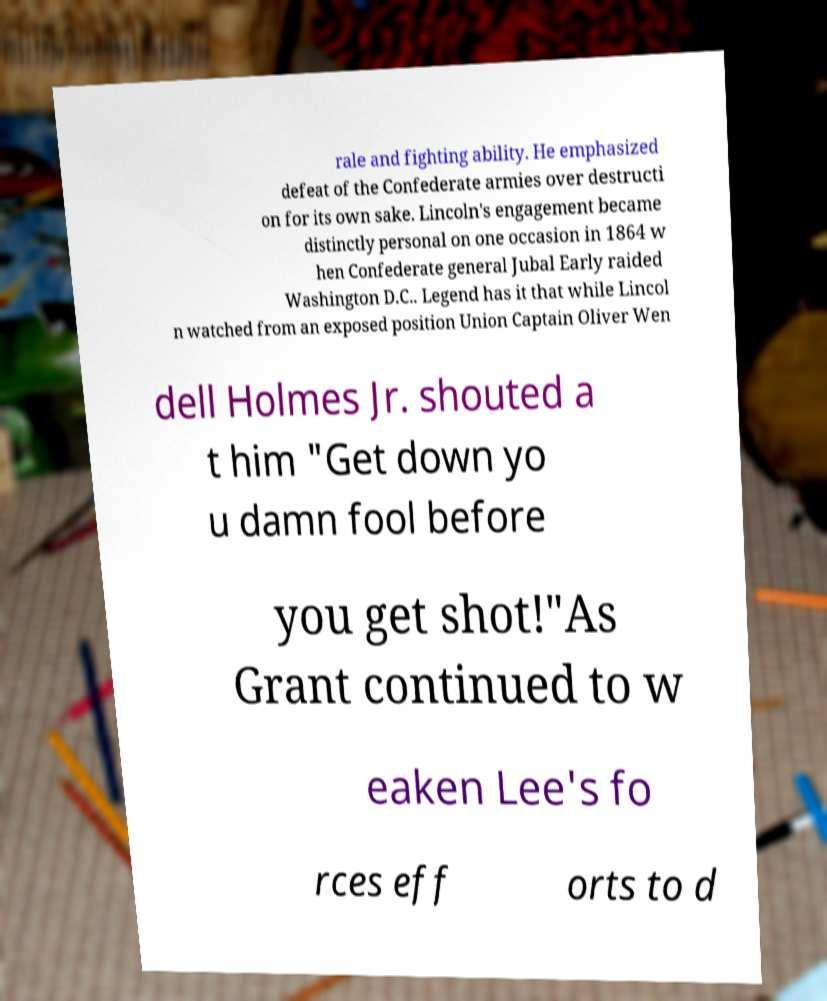Can you read and provide the text displayed in the image?This photo seems to have some interesting text. Can you extract and type it out for me? rale and fighting ability. He emphasized defeat of the Confederate armies over destructi on for its own sake. Lincoln's engagement became distinctly personal on one occasion in 1864 w hen Confederate general Jubal Early raided Washington D.C.. Legend has it that while Lincol n watched from an exposed position Union Captain Oliver Wen dell Holmes Jr. shouted a t him "Get down yo u damn fool before you get shot!"As Grant continued to w eaken Lee's fo rces eff orts to d 